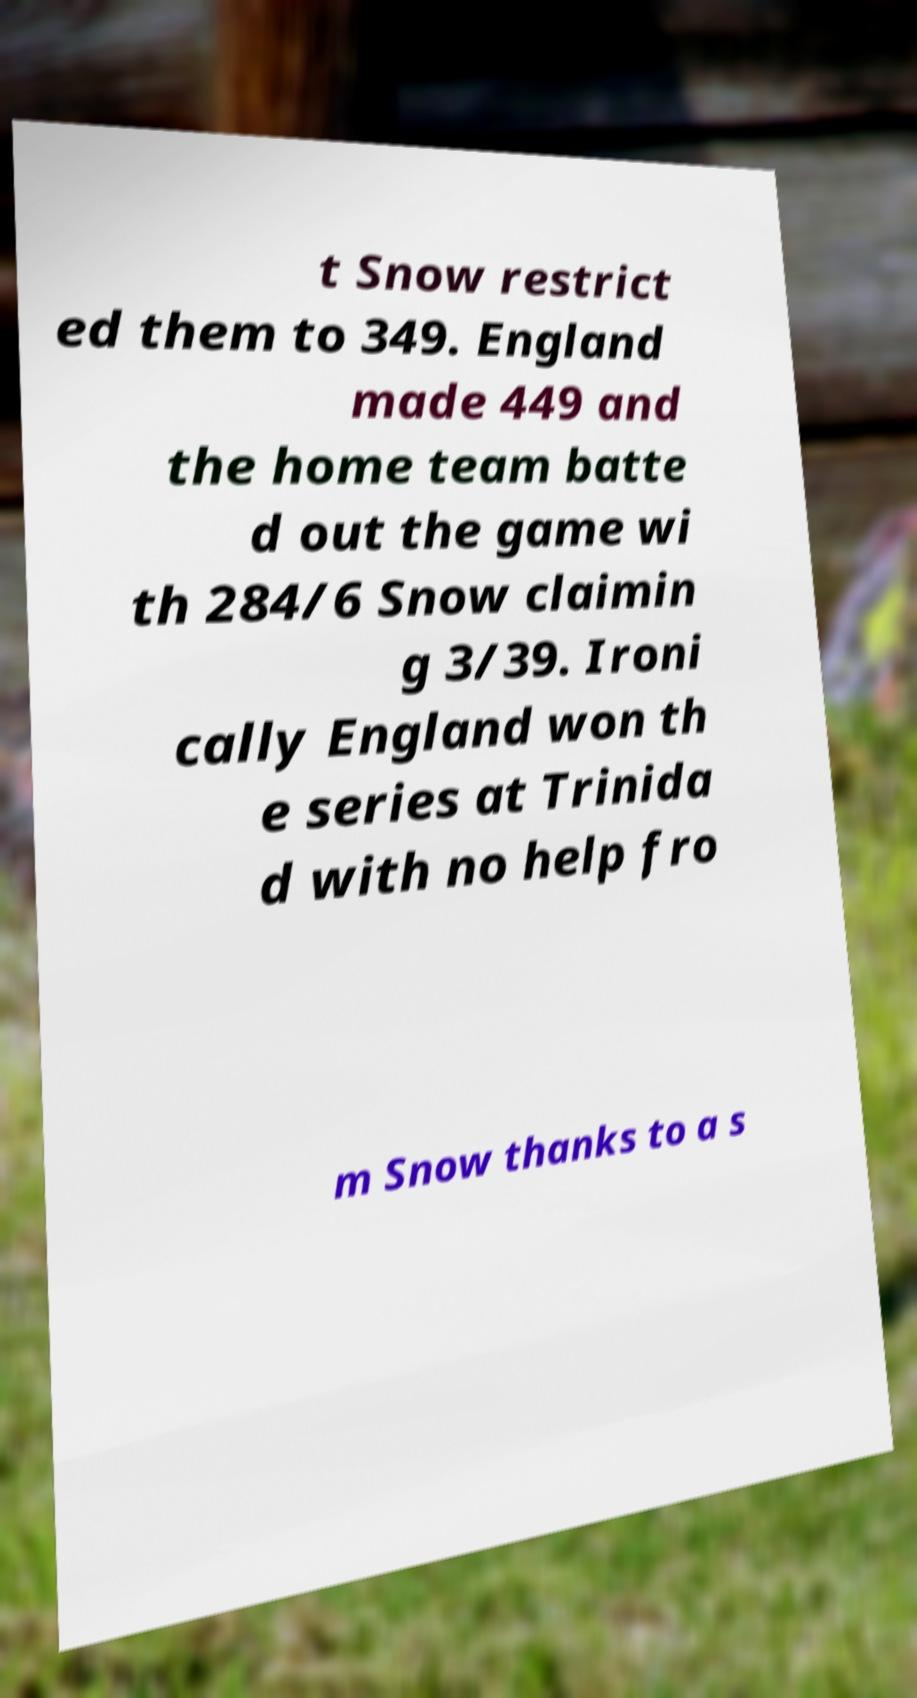Can you read and provide the text displayed in the image?This photo seems to have some interesting text. Can you extract and type it out for me? t Snow restrict ed them to 349. England made 449 and the home team batte d out the game wi th 284/6 Snow claimin g 3/39. Ironi cally England won th e series at Trinida d with no help fro m Snow thanks to a s 